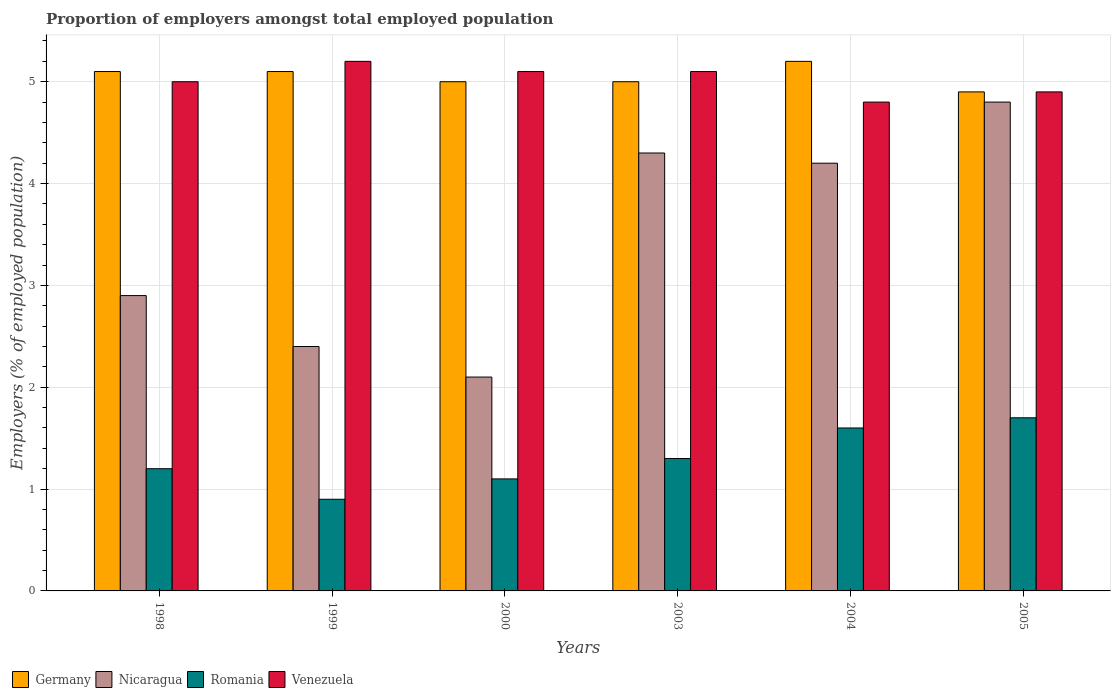How many different coloured bars are there?
Make the answer very short. 4. Are the number of bars on each tick of the X-axis equal?
Make the answer very short. Yes. How many bars are there on the 6th tick from the left?
Give a very brief answer. 4. How many bars are there on the 1st tick from the right?
Offer a terse response. 4. What is the label of the 2nd group of bars from the left?
Make the answer very short. 1999. What is the proportion of employers in Venezuela in 2005?
Make the answer very short. 4.9. Across all years, what is the maximum proportion of employers in Venezuela?
Your response must be concise. 5.2. Across all years, what is the minimum proportion of employers in Venezuela?
Ensure brevity in your answer.  4.8. What is the total proportion of employers in Nicaragua in the graph?
Keep it short and to the point. 20.7. What is the difference between the proportion of employers in Nicaragua in 2004 and that in 2005?
Offer a very short reply. -0.6. What is the difference between the proportion of employers in Nicaragua in 2005 and the proportion of employers in Romania in 2003?
Your answer should be compact. 3.5. What is the average proportion of employers in Nicaragua per year?
Keep it short and to the point. 3.45. In the year 2000, what is the difference between the proportion of employers in Germany and proportion of employers in Venezuela?
Give a very brief answer. -0.1. What is the ratio of the proportion of employers in Germany in 1998 to that in 2000?
Provide a short and direct response. 1.02. What is the difference between the highest and the second highest proportion of employers in Germany?
Give a very brief answer. 0.1. What is the difference between the highest and the lowest proportion of employers in Nicaragua?
Provide a succinct answer. 2.7. Is the sum of the proportion of employers in Romania in 1999 and 2005 greater than the maximum proportion of employers in Germany across all years?
Make the answer very short. No. Is it the case that in every year, the sum of the proportion of employers in Nicaragua and proportion of employers in Romania is greater than the sum of proportion of employers in Venezuela and proportion of employers in Germany?
Ensure brevity in your answer.  No. What does the 4th bar from the left in 2003 represents?
Your answer should be very brief. Venezuela. What does the 4th bar from the right in 2005 represents?
Provide a short and direct response. Germany. Is it the case that in every year, the sum of the proportion of employers in Venezuela and proportion of employers in Germany is greater than the proportion of employers in Romania?
Ensure brevity in your answer.  Yes. Are all the bars in the graph horizontal?
Keep it short and to the point. No. What is the difference between two consecutive major ticks on the Y-axis?
Provide a short and direct response. 1. Are the values on the major ticks of Y-axis written in scientific E-notation?
Give a very brief answer. No. How many legend labels are there?
Offer a very short reply. 4. What is the title of the graph?
Keep it short and to the point. Proportion of employers amongst total employed population. What is the label or title of the Y-axis?
Make the answer very short. Employers (% of employed population). What is the Employers (% of employed population) in Germany in 1998?
Make the answer very short. 5.1. What is the Employers (% of employed population) in Nicaragua in 1998?
Ensure brevity in your answer.  2.9. What is the Employers (% of employed population) of Romania in 1998?
Your answer should be compact. 1.2. What is the Employers (% of employed population) of Germany in 1999?
Your answer should be compact. 5.1. What is the Employers (% of employed population) of Nicaragua in 1999?
Offer a very short reply. 2.4. What is the Employers (% of employed population) of Romania in 1999?
Provide a short and direct response. 0.9. What is the Employers (% of employed population) in Venezuela in 1999?
Provide a short and direct response. 5.2. What is the Employers (% of employed population) of Nicaragua in 2000?
Provide a short and direct response. 2.1. What is the Employers (% of employed population) of Romania in 2000?
Offer a very short reply. 1.1. What is the Employers (% of employed population) in Venezuela in 2000?
Make the answer very short. 5.1. What is the Employers (% of employed population) in Nicaragua in 2003?
Keep it short and to the point. 4.3. What is the Employers (% of employed population) of Romania in 2003?
Ensure brevity in your answer.  1.3. What is the Employers (% of employed population) in Venezuela in 2003?
Make the answer very short. 5.1. What is the Employers (% of employed population) of Germany in 2004?
Make the answer very short. 5.2. What is the Employers (% of employed population) in Nicaragua in 2004?
Your response must be concise. 4.2. What is the Employers (% of employed population) of Romania in 2004?
Provide a succinct answer. 1.6. What is the Employers (% of employed population) of Venezuela in 2004?
Your response must be concise. 4.8. What is the Employers (% of employed population) in Germany in 2005?
Give a very brief answer. 4.9. What is the Employers (% of employed population) in Nicaragua in 2005?
Provide a short and direct response. 4.8. What is the Employers (% of employed population) of Romania in 2005?
Offer a very short reply. 1.7. What is the Employers (% of employed population) of Venezuela in 2005?
Your answer should be compact. 4.9. Across all years, what is the maximum Employers (% of employed population) of Germany?
Give a very brief answer. 5.2. Across all years, what is the maximum Employers (% of employed population) of Nicaragua?
Ensure brevity in your answer.  4.8. Across all years, what is the maximum Employers (% of employed population) in Romania?
Offer a terse response. 1.7. Across all years, what is the maximum Employers (% of employed population) of Venezuela?
Offer a terse response. 5.2. Across all years, what is the minimum Employers (% of employed population) in Germany?
Ensure brevity in your answer.  4.9. Across all years, what is the minimum Employers (% of employed population) of Nicaragua?
Provide a succinct answer. 2.1. Across all years, what is the minimum Employers (% of employed population) in Romania?
Your response must be concise. 0.9. Across all years, what is the minimum Employers (% of employed population) in Venezuela?
Provide a succinct answer. 4.8. What is the total Employers (% of employed population) in Germany in the graph?
Your answer should be very brief. 30.3. What is the total Employers (% of employed population) in Nicaragua in the graph?
Ensure brevity in your answer.  20.7. What is the total Employers (% of employed population) in Venezuela in the graph?
Your response must be concise. 30.1. What is the difference between the Employers (% of employed population) in Germany in 1998 and that in 1999?
Give a very brief answer. 0. What is the difference between the Employers (% of employed population) in Romania in 1998 and that in 1999?
Keep it short and to the point. 0.3. What is the difference between the Employers (% of employed population) of Venezuela in 1998 and that in 1999?
Make the answer very short. -0.2. What is the difference between the Employers (% of employed population) of Germany in 1998 and that in 2000?
Your response must be concise. 0.1. What is the difference between the Employers (% of employed population) of Nicaragua in 1998 and that in 2000?
Give a very brief answer. 0.8. What is the difference between the Employers (% of employed population) of Venezuela in 1998 and that in 2000?
Make the answer very short. -0.1. What is the difference between the Employers (% of employed population) of Germany in 1998 and that in 2003?
Give a very brief answer. 0.1. What is the difference between the Employers (% of employed population) in Romania in 1998 and that in 2003?
Your response must be concise. -0.1. What is the difference between the Employers (% of employed population) in Venezuela in 1998 and that in 2003?
Make the answer very short. -0.1. What is the difference between the Employers (% of employed population) of Germany in 1998 and that in 2004?
Provide a short and direct response. -0.1. What is the difference between the Employers (% of employed population) in Nicaragua in 1998 and that in 2004?
Make the answer very short. -1.3. What is the difference between the Employers (% of employed population) of Romania in 1998 and that in 2004?
Your answer should be compact. -0.4. What is the difference between the Employers (% of employed population) of Venezuela in 1998 and that in 2004?
Your answer should be very brief. 0.2. What is the difference between the Employers (% of employed population) in Germany in 1998 and that in 2005?
Offer a very short reply. 0.2. What is the difference between the Employers (% of employed population) in Venezuela in 1998 and that in 2005?
Give a very brief answer. 0.1. What is the difference between the Employers (% of employed population) of Nicaragua in 1999 and that in 2000?
Your answer should be very brief. 0.3. What is the difference between the Employers (% of employed population) in Romania in 1999 and that in 2000?
Give a very brief answer. -0.2. What is the difference between the Employers (% of employed population) of Venezuela in 1999 and that in 2000?
Provide a short and direct response. 0.1. What is the difference between the Employers (% of employed population) in Germany in 1999 and that in 2004?
Give a very brief answer. -0.1. What is the difference between the Employers (% of employed population) of Venezuela in 1999 and that in 2004?
Give a very brief answer. 0.4. What is the difference between the Employers (% of employed population) in Venezuela in 1999 and that in 2005?
Ensure brevity in your answer.  0.3. What is the difference between the Employers (% of employed population) in Nicaragua in 2000 and that in 2003?
Give a very brief answer. -2.2. What is the difference between the Employers (% of employed population) of Romania in 2000 and that in 2005?
Ensure brevity in your answer.  -0.6. What is the difference between the Employers (% of employed population) of Germany in 2003 and that in 2004?
Make the answer very short. -0.2. What is the difference between the Employers (% of employed population) in Nicaragua in 2003 and that in 2005?
Your response must be concise. -0.5. What is the difference between the Employers (% of employed population) of Romania in 2003 and that in 2005?
Provide a short and direct response. -0.4. What is the difference between the Employers (% of employed population) of Venezuela in 2003 and that in 2005?
Ensure brevity in your answer.  0.2. What is the difference between the Employers (% of employed population) in Germany in 2004 and that in 2005?
Keep it short and to the point. 0.3. What is the difference between the Employers (% of employed population) of Venezuela in 2004 and that in 2005?
Give a very brief answer. -0.1. What is the difference between the Employers (% of employed population) of Germany in 1998 and the Employers (% of employed population) of Romania in 1999?
Your response must be concise. 4.2. What is the difference between the Employers (% of employed population) in Germany in 1998 and the Employers (% of employed population) in Venezuela in 1999?
Offer a very short reply. -0.1. What is the difference between the Employers (% of employed population) in Nicaragua in 1998 and the Employers (% of employed population) in Romania in 1999?
Offer a very short reply. 2. What is the difference between the Employers (% of employed population) in Nicaragua in 1998 and the Employers (% of employed population) in Venezuela in 1999?
Provide a short and direct response. -2.3. What is the difference between the Employers (% of employed population) of Germany in 1998 and the Employers (% of employed population) of Romania in 2000?
Your response must be concise. 4. What is the difference between the Employers (% of employed population) in Germany in 1998 and the Employers (% of employed population) in Venezuela in 2000?
Your answer should be compact. 0. What is the difference between the Employers (% of employed population) of Nicaragua in 1998 and the Employers (% of employed population) of Romania in 2003?
Make the answer very short. 1.6. What is the difference between the Employers (% of employed population) in Romania in 1998 and the Employers (% of employed population) in Venezuela in 2003?
Give a very brief answer. -3.9. What is the difference between the Employers (% of employed population) of Germany in 1998 and the Employers (% of employed population) of Venezuela in 2004?
Provide a short and direct response. 0.3. What is the difference between the Employers (% of employed population) in Nicaragua in 1998 and the Employers (% of employed population) in Romania in 2004?
Your answer should be compact. 1.3. What is the difference between the Employers (% of employed population) of Nicaragua in 1998 and the Employers (% of employed population) of Venezuela in 2004?
Your response must be concise. -1.9. What is the difference between the Employers (% of employed population) in Romania in 1998 and the Employers (% of employed population) in Venezuela in 2004?
Offer a terse response. -3.6. What is the difference between the Employers (% of employed population) of Germany in 1998 and the Employers (% of employed population) of Venezuela in 2005?
Your response must be concise. 0.2. What is the difference between the Employers (% of employed population) of Nicaragua in 1998 and the Employers (% of employed population) of Romania in 2005?
Your answer should be very brief. 1.2. What is the difference between the Employers (% of employed population) in Nicaragua in 1998 and the Employers (% of employed population) in Venezuela in 2005?
Your answer should be very brief. -2. What is the difference between the Employers (% of employed population) of Romania in 1998 and the Employers (% of employed population) of Venezuela in 2005?
Offer a very short reply. -3.7. What is the difference between the Employers (% of employed population) of Germany in 1999 and the Employers (% of employed population) of Nicaragua in 2003?
Ensure brevity in your answer.  0.8. What is the difference between the Employers (% of employed population) in Germany in 1999 and the Employers (% of employed population) in Venezuela in 2003?
Offer a terse response. 0. What is the difference between the Employers (% of employed population) in Nicaragua in 1999 and the Employers (% of employed population) in Romania in 2003?
Ensure brevity in your answer.  1.1. What is the difference between the Employers (% of employed population) in Romania in 1999 and the Employers (% of employed population) in Venezuela in 2003?
Your answer should be very brief. -4.2. What is the difference between the Employers (% of employed population) in Germany in 1999 and the Employers (% of employed population) in Nicaragua in 2004?
Ensure brevity in your answer.  0.9. What is the difference between the Employers (% of employed population) of Nicaragua in 1999 and the Employers (% of employed population) of Venezuela in 2004?
Your answer should be compact. -2.4. What is the difference between the Employers (% of employed population) of Germany in 1999 and the Employers (% of employed population) of Nicaragua in 2005?
Keep it short and to the point. 0.3. What is the difference between the Employers (% of employed population) in Germany in 1999 and the Employers (% of employed population) in Romania in 2005?
Make the answer very short. 3.4. What is the difference between the Employers (% of employed population) of Romania in 1999 and the Employers (% of employed population) of Venezuela in 2005?
Offer a very short reply. -4. What is the difference between the Employers (% of employed population) in Germany in 2000 and the Employers (% of employed population) in Romania in 2003?
Provide a short and direct response. 3.7. What is the difference between the Employers (% of employed population) of Germany in 2000 and the Employers (% of employed population) of Venezuela in 2003?
Ensure brevity in your answer.  -0.1. What is the difference between the Employers (% of employed population) of Nicaragua in 2000 and the Employers (% of employed population) of Venezuela in 2003?
Your answer should be compact. -3. What is the difference between the Employers (% of employed population) in Germany in 2000 and the Employers (% of employed population) in Romania in 2004?
Provide a short and direct response. 3.4. What is the difference between the Employers (% of employed population) of Germany in 2000 and the Employers (% of employed population) of Venezuela in 2004?
Offer a very short reply. 0.2. What is the difference between the Employers (% of employed population) in Nicaragua in 2000 and the Employers (% of employed population) in Romania in 2004?
Your answer should be very brief. 0.5. What is the difference between the Employers (% of employed population) of Nicaragua in 2000 and the Employers (% of employed population) of Venezuela in 2004?
Your response must be concise. -2.7. What is the difference between the Employers (% of employed population) of Romania in 2000 and the Employers (% of employed population) of Venezuela in 2004?
Make the answer very short. -3.7. What is the difference between the Employers (% of employed population) in Germany in 2000 and the Employers (% of employed population) in Nicaragua in 2005?
Keep it short and to the point. 0.2. What is the difference between the Employers (% of employed population) in Nicaragua in 2000 and the Employers (% of employed population) in Romania in 2005?
Give a very brief answer. 0.4. What is the difference between the Employers (% of employed population) of Nicaragua in 2000 and the Employers (% of employed population) of Venezuela in 2005?
Ensure brevity in your answer.  -2.8. What is the difference between the Employers (% of employed population) in Romania in 2000 and the Employers (% of employed population) in Venezuela in 2005?
Your response must be concise. -3.8. What is the difference between the Employers (% of employed population) of Germany in 2003 and the Employers (% of employed population) of Nicaragua in 2004?
Your answer should be very brief. 0.8. What is the difference between the Employers (% of employed population) in Germany in 2003 and the Employers (% of employed population) in Venezuela in 2004?
Your answer should be compact. 0.2. What is the difference between the Employers (% of employed population) in Nicaragua in 2003 and the Employers (% of employed population) in Venezuela in 2004?
Provide a short and direct response. -0.5. What is the difference between the Employers (% of employed population) of Nicaragua in 2003 and the Employers (% of employed population) of Romania in 2005?
Provide a short and direct response. 2.6. What is the difference between the Employers (% of employed population) in Nicaragua in 2003 and the Employers (% of employed population) in Venezuela in 2005?
Offer a terse response. -0.6. What is the difference between the Employers (% of employed population) in Germany in 2004 and the Employers (% of employed population) in Nicaragua in 2005?
Your answer should be very brief. 0.4. What is the difference between the Employers (% of employed population) of Nicaragua in 2004 and the Employers (% of employed population) of Romania in 2005?
Offer a very short reply. 2.5. What is the difference between the Employers (% of employed population) in Romania in 2004 and the Employers (% of employed population) in Venezuela in 2005?
Offer a very short reply. -3.3. What is the average Employers (% of employed population) in Germany per year?
Give a very brief answer. 5.05. What is the average Employers (% of employed population) of Nicaragua per year?
Your answer should be very brief. 3.45. What is the average Employers (% of employed population) in Venezuela per year?
Give a very brief answer. 5.02. In the year 1998, what is the difference between the Employers (% of employed population) of Nicaragua and Employers (% of employed population) of Romania?
Provide a succinct answer. 1.7. In the year 1998, what is the difference between the Employers (% of employed population) of Nicaragua and Employers (% of employed population) of Venezuela?
Ensure brevity in your answer.  -2.1. In the year 1998, what is the difference between the Employers (% of employed population) in Romania and Employers (% of employed population) in Venezuela?
Your response must be concise. -3.8. In the year 1999, what is the difference between the Employers (% of employed population) of Germany and Employers (% of employed population) of Nicaragua?
Offer a very short reply. 2.7. In the year 1999, what is the difference between the Employers (% of employed population) of Germany and Employers (% of employed population) of Romania?
Your response must be concise. 4.2. In the year 1999, what is the difference between the Employers (% of employed population) in Germany and Employers (% of employed population) in Venezuela?
Offer a terse response. -0.1. In the year 1999, what is the difference between the Employers (% of employed population) of Nicaragua and Employers (% of employed population) of Romania?
Provide a succinct answer. 1.5. In the year 1999, what is the difference between the Employers (% of employed population) in Nicaragua and Employers (% of employed population) in Venezuela?
Give a very brief answer. -2.8. In the year 1999, what is the difference between the Employers (% of employed population) of Romania and Employers (% of employed population) of Venezuela?
Your answer should be very brief. -4.3. In the year 2000, what is the difference between the Employers (% of employed population) in Germany and Employers (% of employed population) in Nicaragua?
Ensure brevity in your answer.  2.9. In the year 2000, what is the difference between the Employers (% of employed population) of Germany and Employers (% of employed population) of Romania?
Ensure brevity in your answer.  3.9. In the year 2000, what is the difference between the Employers (% of employed population) of Nicaragua and Employers (% of employed population) of Romania?
Offer a very short reply. 1. In the year 2003, what is the difference between the Employers (% of employed population) of Germany and Employers (% of employed population) of Nicaragua?
Your answer should be very brief. 0.7. In the year 2003, what is the difference between the Employers (% of employed population) in Nicaragua and Employers (% of employed population) in Romania?
Ensure brevity in your answer.  3. In the year 2003, what is the difference between the Employers (% of employed population) of Nicaragua and Employers (% of employed population) of Venezuela?
Offer a very short reply. -0.8. In the year 2004, what is the difference between the Employers (% of employed population) in Germany and Employers (% of employed population) in Nicaragua?
Provide a short and direct response. 1. In the year 2004, what is the difference between the Employers (% of employed population) in Nicaragua and Employers (% of employed population) in Romania?
Offer a very short reply. 2.6. In the year 2004, what is the difference between the Employers (% of employed population) of Nicaragua and Employers (% of employed population) of Venezuela?
Keep it short and to the point. -0.6. In the year 2005, what is the difference between the Employers (% of employed population) of Germany and Employers (% of employed population) of Nicaragua?
Your response must be concise. 0.1. In the year 2005, what is the difference between the Employers (% of employed population) of Romania and Employers (% of employed population) of Venezuela?
Provide a succinct answer. -3.2. What is the ratio of the Employers (% of employed population) of Nicaragua in 1998 to that in 1999?
Offer a terse response. 1.21. What is the ratio of the Employers (% of employed population) of Romania in 1998 to that in 1999?
Make the answer very short. 1.33. What is the ratio of the Employers (% of employed population) in Venezuela in 1998 to that in 1999?
Your response must be concise. 0.96. What is the ratio of the Employers (% of employed population) of Nicaragua in 1998 to that in 2000?
Make the answer very short. 1.38. What is the ratio of the Employers (% of employed population) of Venezuela in 1998 to that in 2000?
Make the answer very short. 0.98. What is the ratio of the Employers (% of employed population) in Nicaragua in 1998 to that in 2003?
Provide a succinct answer. 0.67. What is the ratio of the Employers (% of employed population) of Romania in 1998 to that in 2003?
Your response must be concise. 0.92. What is the ratio of the Employers (% of employed population) of Venezuela in 1998 to that in 2003?
Offer a very short reply. 0.98. What is the ratio of the Employers (% of employed population) in Germany in 1998 to that in 2004?
Provide a short and direct response. 0.98. What is the ratio of the Employers (% of employed population) in Nicaragua in 1998 to that in 2004?
Your answer should be compact. 0.69. What is the ratio of the Employers (% of employed population) of Romania in 1998 to that in 2004?
Offer a very short reply. 0.75. What is the ratio of the Employers (% of employed population) of Venezuela in 1998 to that in 2004?
Provide a succinct answer. 1.04. What is the ratio of the Employers (% of employed population) of Germany in 1998 to that in 2005?
Give a very brief answer. 1.04. What is the ratio of the Employers (% of employed population) of Nicaragua in 1998 to that in 2005?
Offer a very short reply. 0.6. What is the ratio of the Employers (% of employed population) of Romania in 1998 to that in 2005?
Give a very brief answer. 0.71. What is the ratio of the Employers (% of employed population) in Venezuela in 1998 to that in 2005?
Offer a very short reply. 1.02. What is the ratio of the Employers (% of employed population) in Romania in 1999 to that in 2000?
Give a very brief answer. 0.82. What is the ratio of the Employers (% of employed population) of Venezuela in 1999 to that in 2000?
Give a very brief answer. 1.02. What is the ratio of the Employers (% of employed population) in Germany in 1999 to that in 2003?
Provide a short and direct response. 1.02. What is the ratio of the Employers (% of employed population) in Nicaragua in 1999 to that in 2003?
Keep it short and to the point. 0.56. What is the ratio of the Employers (% of employed population) of Romania in 1999 to that in 2003?
Your response must be concise. 0.69. What is the ratio of the Employers (% of employed population) in Venezuela in 1999 to that in 2003?
Keep it short and to the point. 1.02. What is the ratio of the Employers (% of employed population) in Germany in 1999 to that in 2004?
Provide a succinct answer. 0.98. What is the ratio of the Employers (% of employed population) in Nicaragua in 1999 to that in 2004?
Give a very brief answer. 0.57. What is the ratio of the Employers (% of employed population) of Romania in 1999 to that in 2004?
Provide a succinct answer. 0.56. What is the ratio of the Employers (% of employed population) of Venezuela in 1999 to that in 2004?
Give a very brief answer. 1.08. What is the ratio of the Employers (% of employed population) in Germany in 1999 to that in 2005?
Your answer should be very brief. 1.04. What is the ratio of the Employers (% of employed population) in Romania in 1999 to that in 2005?
Your answer should be compact. 0.53. What is the ratio of the Employers (% of employed population) of Venezuela in 1999 to that in 2005?
Your answer should be very brief. 1.06. What is the ratio of the Employers (% of employed population) in Germany in 2000 to that in 2003?
Your response must be concise. 1. What is the ratio of the Employers (% of employed population) in Nicaragua in 2000 to that in 2003?
Offer a terse response. 0.49. What is the ratio of the Employers (% of employed population) of Romania in 2000 to that in 2003?
Offer a very short reply. 0.85. What is the ratio of the Employers (% of employed population) of Germany in 2000 to that in 2004?
Make the answer very short. 0.96. What is the ratio of the Employers (% of employed population) in Romania in 2000 to that in 2004?
Provide a succinct answer. 0.69. What is the ratio of the Employers (% of employed population) in Germany in 2000 to that in 2005?
Ensure brevity in your answer.  1.02. What is the ratio of the Employers (% of employed population) of Nicaragua in 2000 to that in 2005?
Your answer should be compact. 0.44. What is the ratio of the Employers (% of employed population) in Romania in 2000 to that in 2005?
Keep it short and to the point. 0.65. What is the ratio of the Employers (% of employed population) in Venezuela in 2000 to that in 2005?
Provide a short and direct response. 1.04. What is the ratio of the Employers (% of employed population) of Germany in 2003 to that in 2004?
Give a very brief answer. 0.96. What is the ratio of the Employers (% of employed population) of Nicaragua in 2003 to that in 2004?
Provide a succinct answer. 1.02. What is the ratio of the Employers (% of employed population) of Romania in 2003 to that in 2004?
Provide a short and direct response. 0.81. What is the ratio of the Employers (% of employed population) in Germany in 2003 to that in 2005?
Ensure brevity in your answer.  1.02. What is the ratio of the Employers (% of employed population) of Nicaragua in 2003 to that in 2005?
Offer a very short reply. 0.9. What is the ratio of the Employers (% of employed population) in Romania in 2003 to that in 2005?
Provide a short and direct response. 0.76. What is the ratio of the Employers (% of employed population) of Venezuela in 2003 to that in 2005?
Your answer should be very brief. 1.04. What is the ratio of the Employers (% of employed population) in Germany in 2004 to that in 2005?
Your answer should be compact. 1.06. What is the ratio of the Employers (% of employed population) of Nicaragua in 2004 to that in 2005?
Keep it short and to the point. 0.88. What is the ratio of the Employers (% of employed population) in Romania in 2004 to that in 2005?
Give a very brief answer. 0.94. What is the ratio of the Employers (% of employed population) in Venezuela in 2004 to that in 2005?
Your answer should be compact. 0.98. What is the difference between the highest and the second highest Employers (% of employed population) in Germany?
Provide a short and direct response. 0.1. What is the difference between the highest and the second highest Employers (% of employed population) of Venezuela?
Your response must be concise. 0.1. What is the difference between the highest and the lowest Employers (% of employed population) in Romania?
Offer a very short reply. 0.8. 